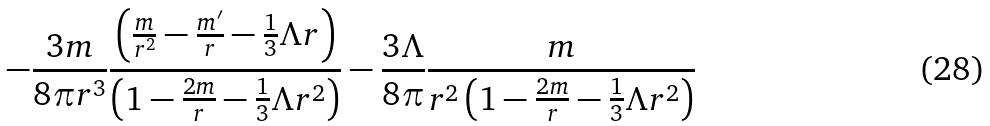<formula> <loc_0><loc_0><loc_500><loc_500>- \frac { 3 m } { 8 \pi r ^ { 3 } } \frac { \left ( \frac { m } { r ^ { 2 } } - \frac { m ^ { \prime } } { r } - \frac { 1 } { 3 } \Lambda r \right ) } { \left ( 1 - \frac { 2 m } { r } - \frac { 1 } { 3 } \Lambda r ^ { 2 } \right ) } - \frac { 3 \Lambda } { 8 \pi } \frac { m } { r ^ { 2 } \left ( 1 - \frac { 2 m } { r } - \frac { 1 } { 3 } \Lambda r ^ { 2 } \right ) }</formula> 